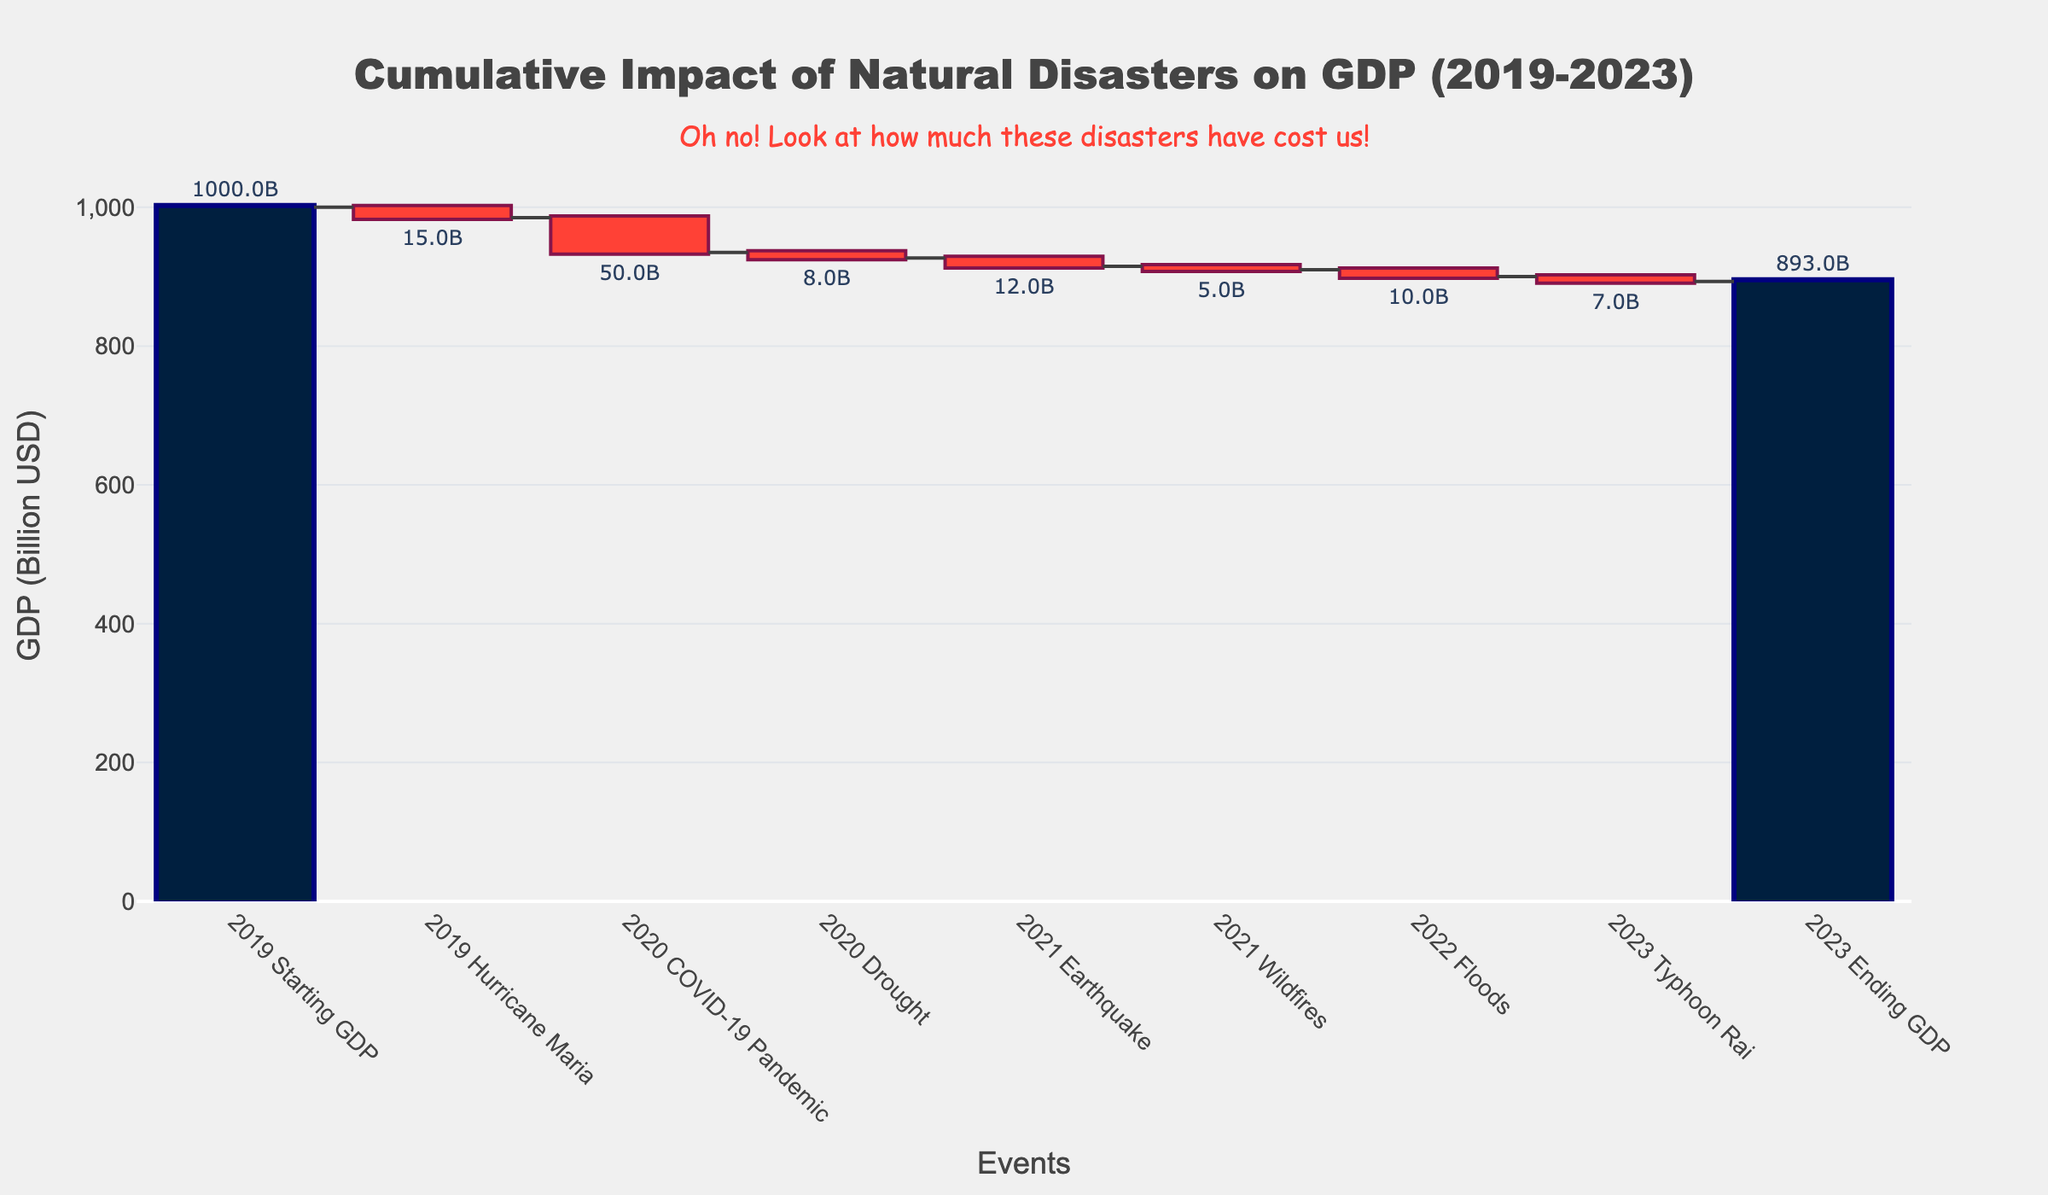How many events are shown in the chart? Count all the events listed on the x-axis. Including the starting and ending GDP, there are 7 events: Hurricane Maria, COVID-19 Pandemic, Drought, Earthquake, Wildfires, Floods, Typhoon Rai.
Answer: 7 What is the total impact on GDP by the end of 2023? The ending GDP is provided directly in the chart. It is 893 billion USD.
Answer: 893 billion USD Which event caused the highest negative impact on GDP? Look for the event with the most significant downward bar. COVID-19 Pandemic shows the biggest decrease in GDP, with a value of -50 billion USD.
Answer: COVID-19 Pandemic How much did the GDP decrease due to Hurricane Maria and Wildfires combined? Sum the impact on GDP of Hurricane Maria (-15 billion USD) and Wildfires (-5 billion USD). -15 + (-5) = -20 billion USD.
Answer: -20 billion USD What was the starting GDP in 2019? Refer to the first value on the y-axis under 'Starting GDP.' It is 1000 billion USD.
Answer: 1000 billion USD Did any event in the chart positively impact the GDP? All events listed have negative values for their impact on GDP, indicating there are no positive impacts.
Answer: No How does the ending GDP in 2023 compare to the starting GDP in 2019? Subtract the ending GDP (893 billion USD) from the starting GDP (1000 billion USD). 1000 - 893 = 107 billion USD decrease.
Answer: Decreased by 107 billion USD What is the average decrease in GDP per event (excluding starting and ending GDP)? Sum all the individual negative impacts: -15 + (-50) + (-8) + (-12) + (-5) + (-10) + (-7) = -107 billion USD. Divide by the number of events (7): -107/7 ≈ -15.29 billion USD per event.
Answer: Approximately -15.29 billion USD Which year experienced the highest total GDP impact from natural disasters? Identify the year with the highest sum of negative impacts. In 2020, the combined impact from COVID-19 Pandemic and Drought is -50 + (-8) = -58 billion USD. Other years have lower totals.
Answer: 2020 